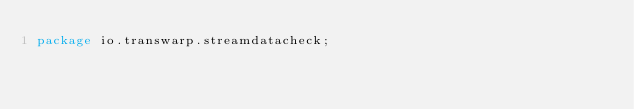Convert code to text. <code><loc_0><loc_0><loc_500><loc_500><_Java_>package io.transwarp.streamdatacheck;
</code> 